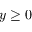<formula> <loc_0><loc_0><loc_500><loc_500>y \geq 0</formula> 